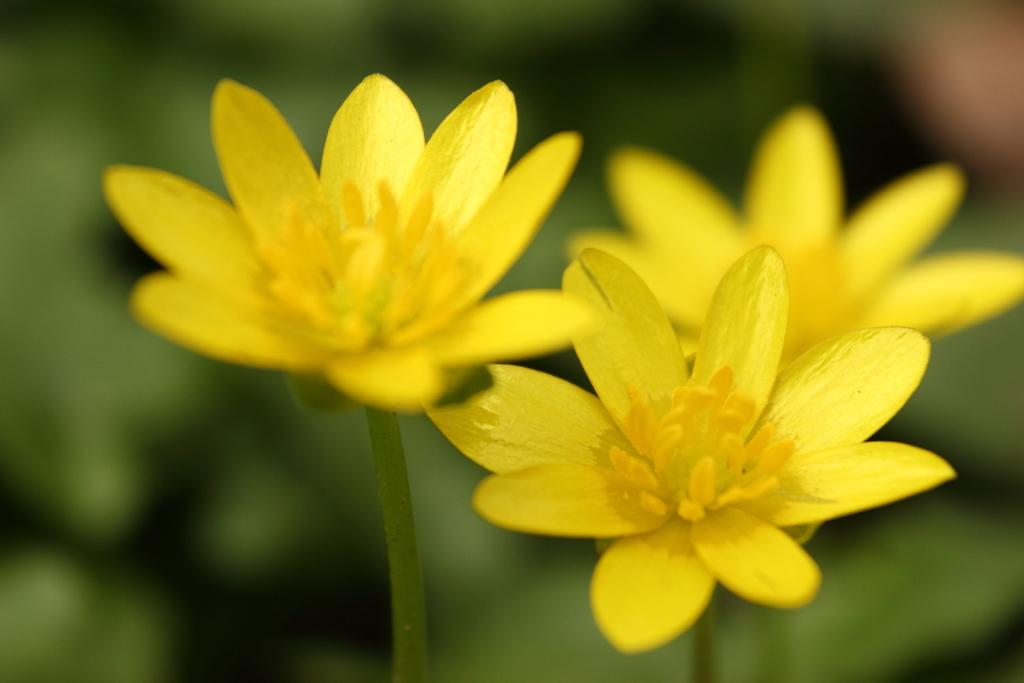What type of plants can be seen in the image? There are flowers in the image. Can you describe the background of the image? The background of the image is blurred. What type of tree is featured in the story being told on the stage in the image? There is no tree, story, or stage present in the image; it only features flowers and a blurred background. 